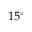Convert formula to latex. <formula><loc_0><loc_0><loc_500><loc_500>1 5 ^ { \circ }</formula> 